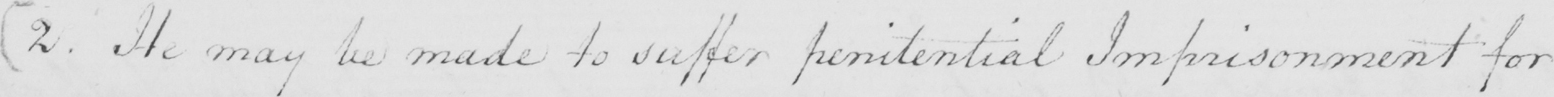Please transcribe the handwritten text in this image. [ 2 . He may be made to suffer penitential Imprisonment for 